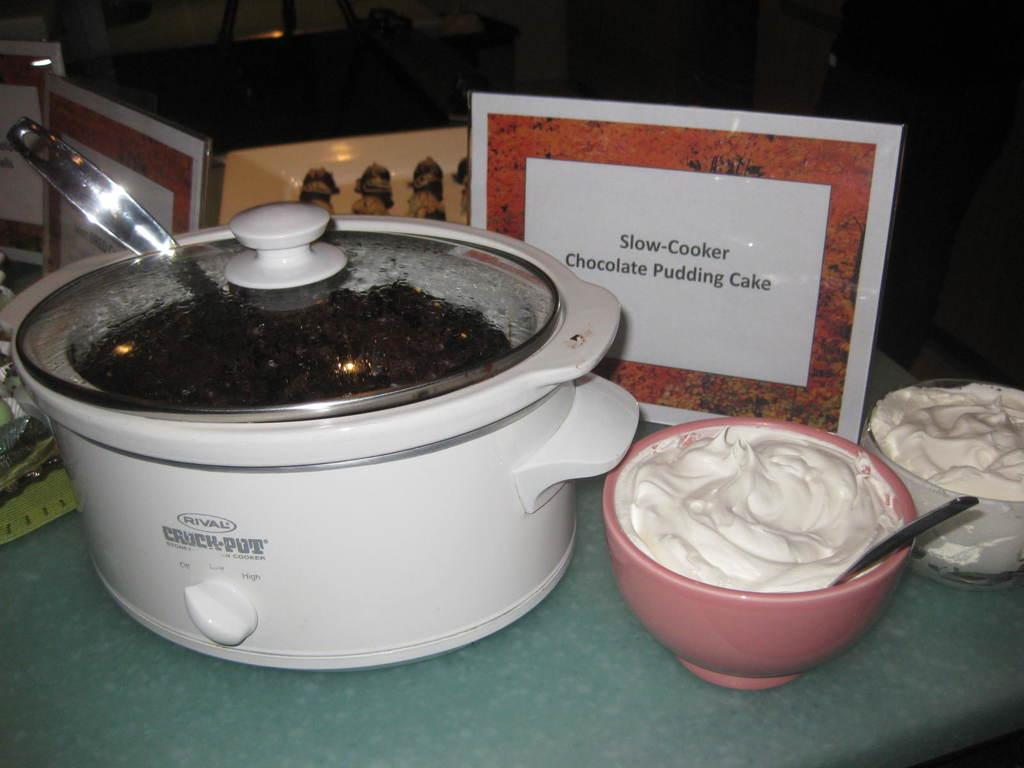<image>
Summarize the visual content of the image. a crock pot with a slow cooker sign next to it 